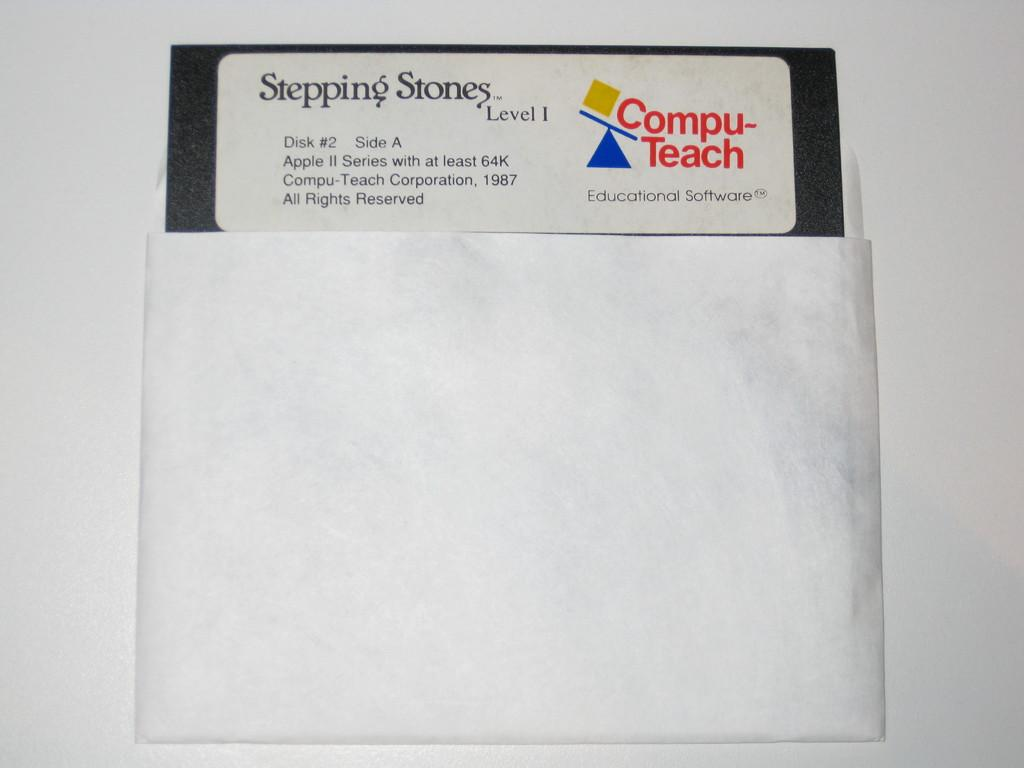<image>
Give a short and clear explanation of the subsequent image. Floppy disk of Stepping Stones Level 1 by Computech software. 